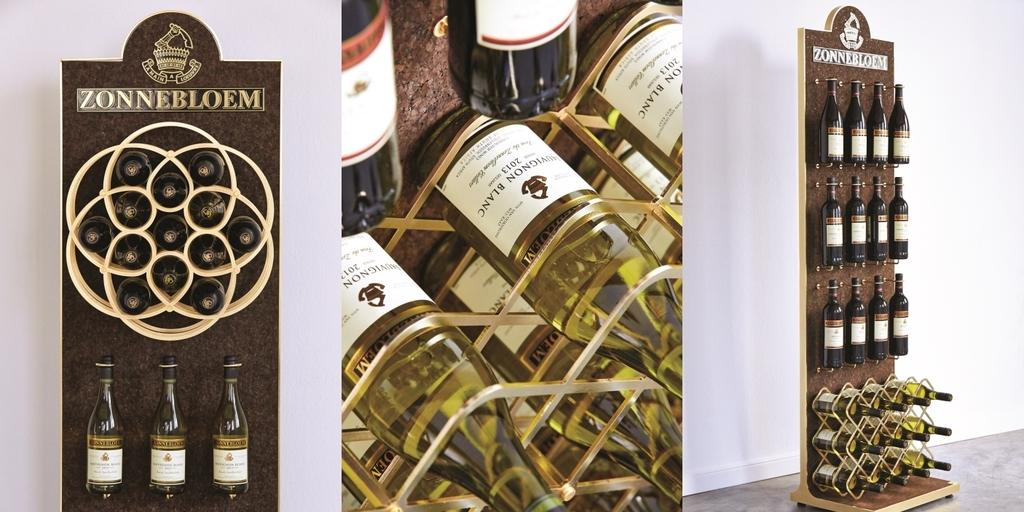What type of artwork is depicted in the image? The image is a collage. What objects can be seen in the collage? There are wine bottles and boards visible in the image. What is in the background of the collage? There is a wall in the background of the image. What part of the floor can be seen in the image? The floor is visible in the bottom right corner of the image. Can you tell me how the river flows in the image? There is no river present in the image; it is a collage featuring wine bottles, boards, a wall, and a visible part of the floor. What type of furniture is in the bedroom in the image? There is no bedroom depicted in the image; it is a collage with various objects and a background wall. 